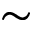<formula> <loc_0><loc_0><loc_500><loc_500>\sim</formula> 